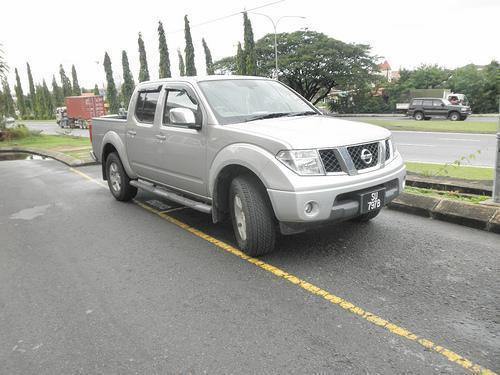What is the luxury division of this motor company?
Make your selection and explain in format: 'Answer: answer
Rationale: rationale.'
Options: Jaguar, lexus, infinity, acura. Answer: infinity.
Rationale: A nissan truck can be seen parked. 